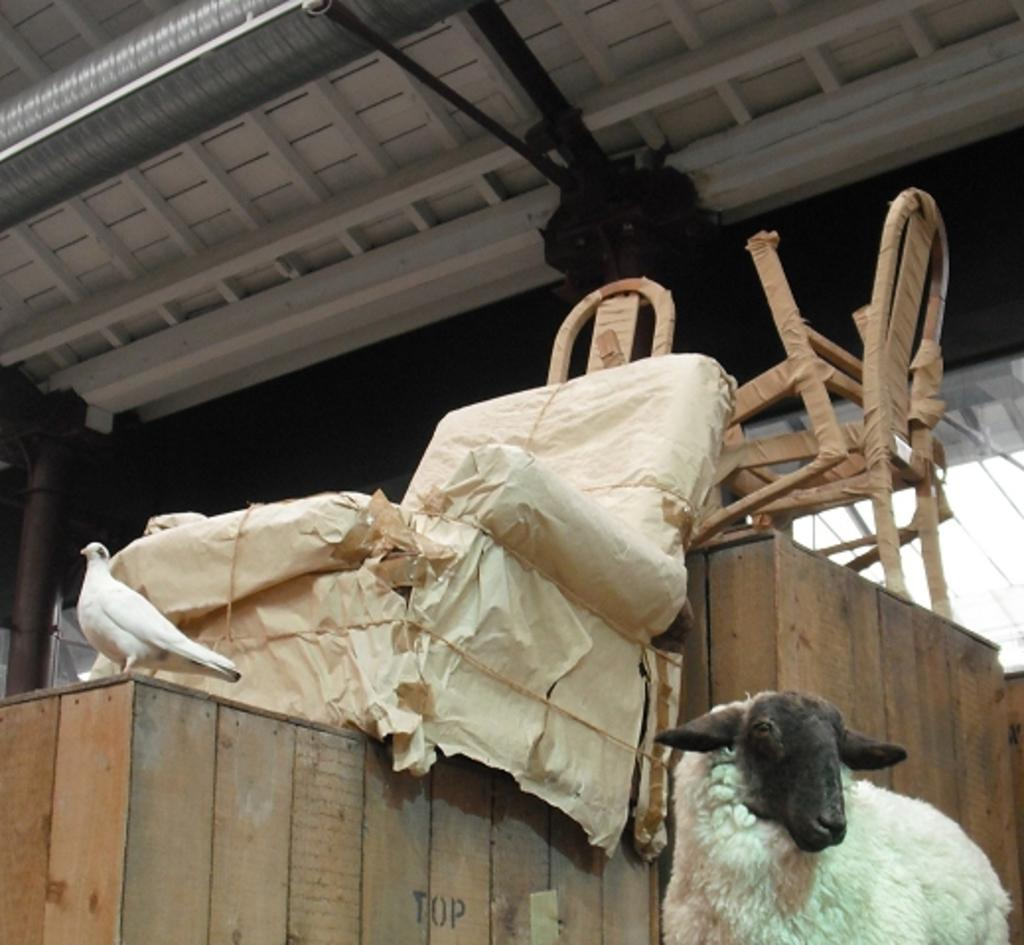What is the main object in the image that is packed and placed on wooden boxes? There is a chair packed and placed on wooden boxes in the image. What animal can be seen beside the wooden boxes? There is a sheep beside the box in the image. What can be seen in the background of the image? There is a ceiling visible in the background of the image. What type of jeans is the sheep wearing in the image? There are no jeans present in the image, as sheep do not wear clothing. What type of powder is being used by the chair in the image? There is no powder present in the image, and chairs do not use powder. 